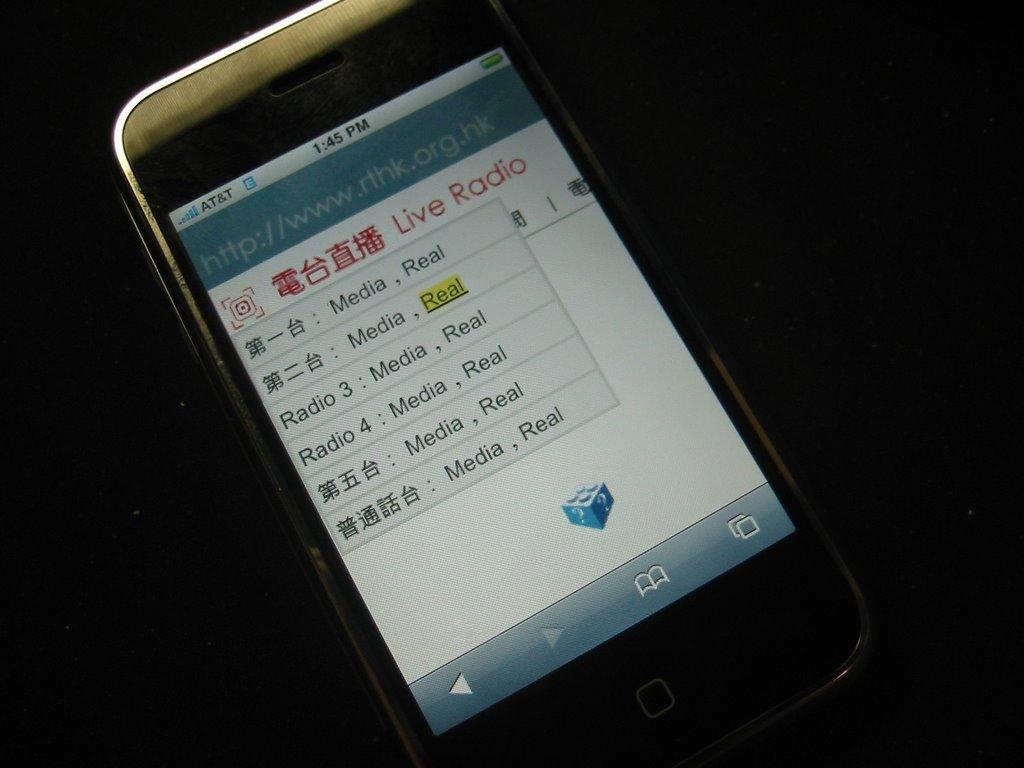<image>
Relay a brief, clear account of the picture shown. A smartphone is shown open to the website http://www.rthk.org/hk which features "Live Radio." 